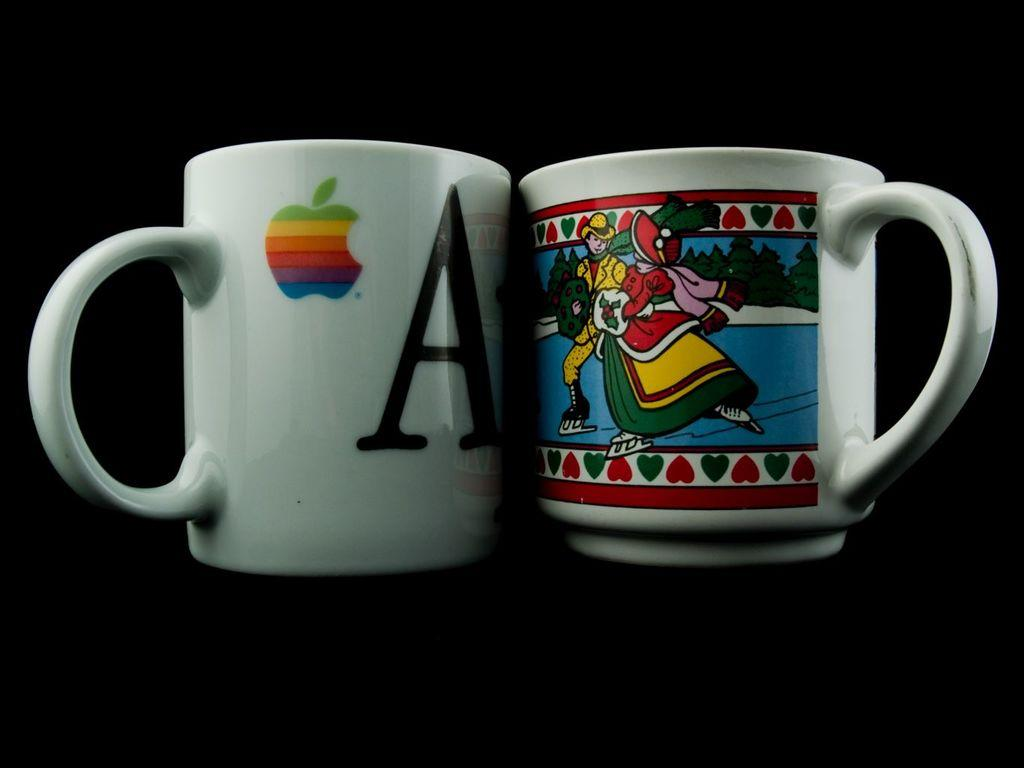<image>
Describe the image concisely. White apple logo on a white cup with the letter A in black on the front. 